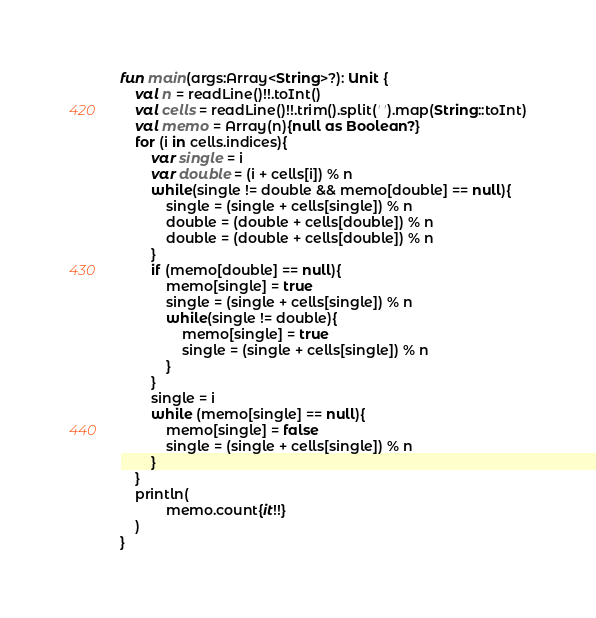Convert code to text. <code><loc_0><loc_0><loc_500><loc_500><_Kotlin_>fun main(args:Array<String>?): Unit {
    val n = readLine()!!.toInt()
    val cells = readLine()!!.trim().split(' ').map(String::toInt)
    val memo = Array(n){null as Boolean?}
    for (i in cells.indices){
        var single = i
        var double = (i + cells[i]) % n
        while(single != double && memo[double] == null){
            single = (single + cells[single]) % n
            double = (double + cells[double]) % n
            double = (double + cells[double]) % n
        }
        if (memo[double] == null){
            memo[single] = true
            single = (single + cells[single]) % n
            while(single != double){
                memo[single] = true
                single = (single + cells[single]) % n
            }
        }
        single = i
        while (memo[single] == null){
            memo[single] = false
            single = (single + cells[single]) % n
        }
    }
    println(
            memo.count{it!!}
    )
}
</code> 